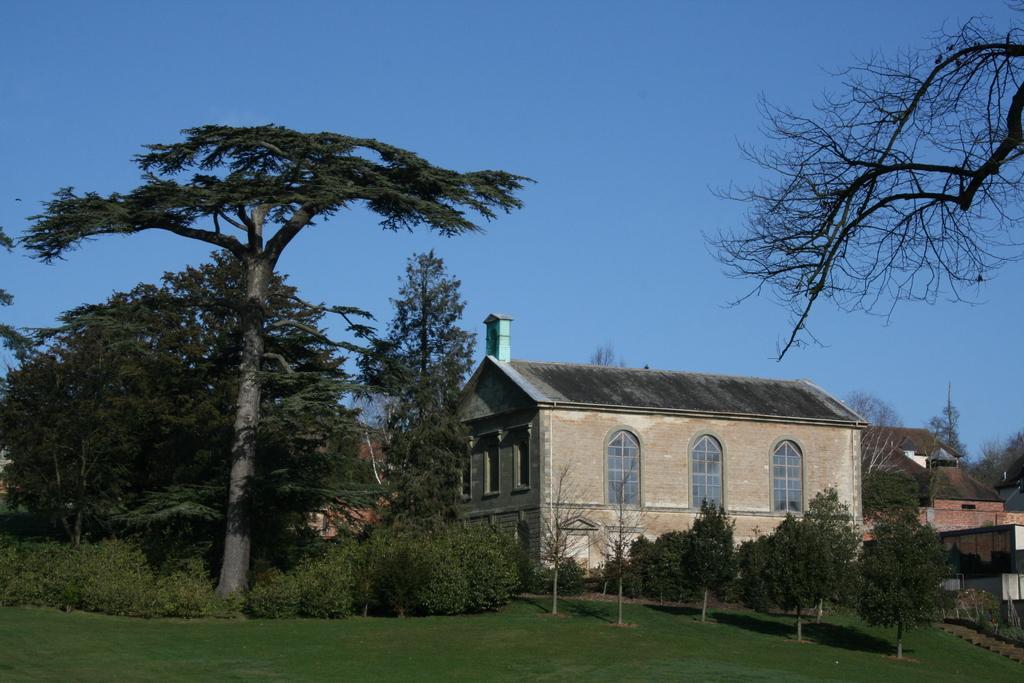How would you summarize this image in a sentence or two? In this picture we can see buildings. On the left we can see many trees and plants. At the bottom we can see green grass. At the top there is a sky. In the bottom right corner we can see stars near to the plant. 